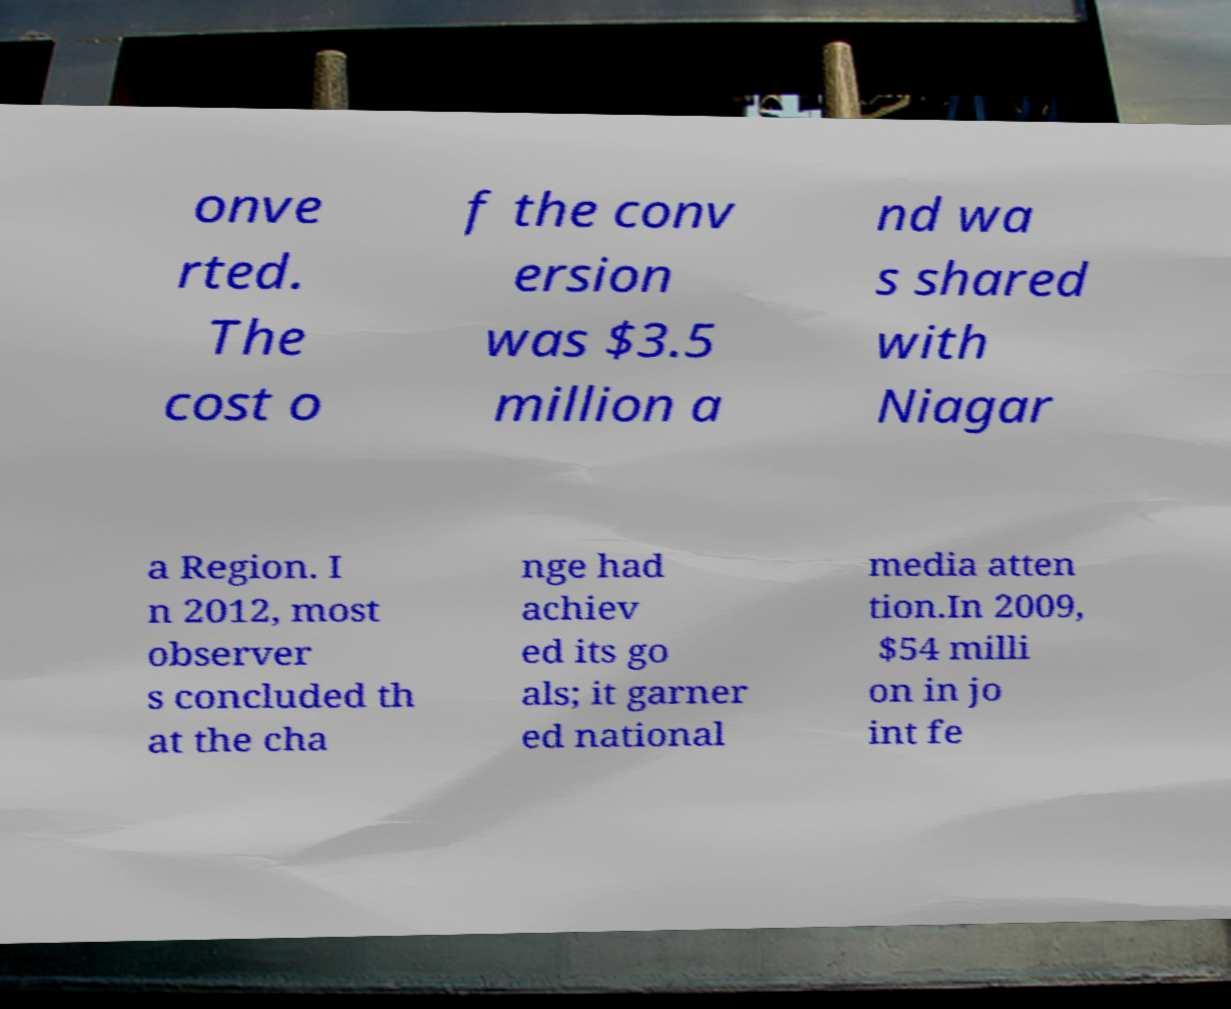Please read and relay the text visible in this image. What does it say? onve rted. The cost o f the conv ersion was $3.5 million a nd wa s shared with Niagar a Region. I n 2012, most observer s concluded th at the cha nge had achiev ed its go als; it garner ed national media atten tion.In 2009, $54 milli on in jo int fe 